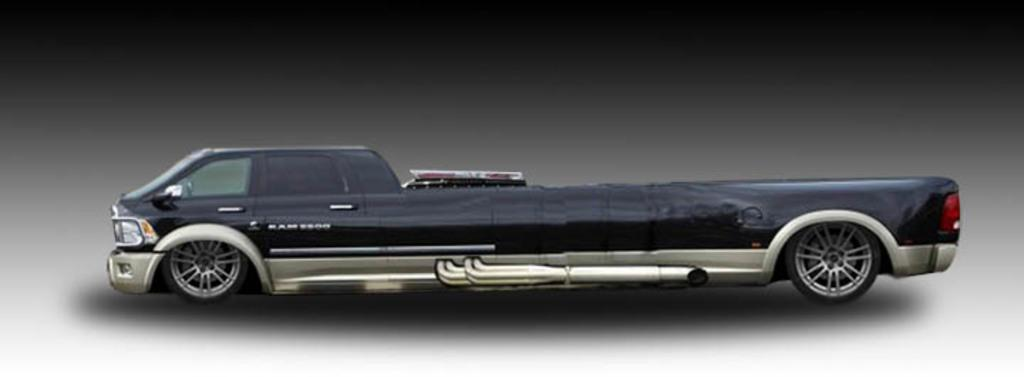What type of toy is in the image? There is a toy truck in the image. What color is the toy truck? The toy truck is black in color. What type of science experiment can be seen in the image? There is no science experiment present in the image; it features a black toy truck. What type of cup is visible in the image? There is no cup present in the image. 